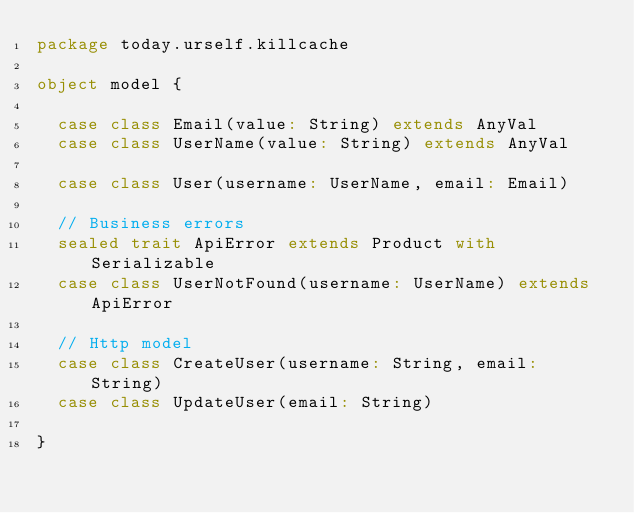<code> <loc_0><loc_0><loc_500><loc_500><_Scala_>package today.urself.killcache

object model {

  case class Email(value: String) extends AnyVal
  case class UserName(value: String) extends AnyVal

  case class User(username: UserName, email: Email)

  // Business errors
  sealed trait ApiError extends Product with Serializable
  case class UserNotFound(username: UserName) extends ApiError

  // Http model
  case class CreateUser(username: String, email: String)
  case class UpdateUser(email: String)

}
</code> 